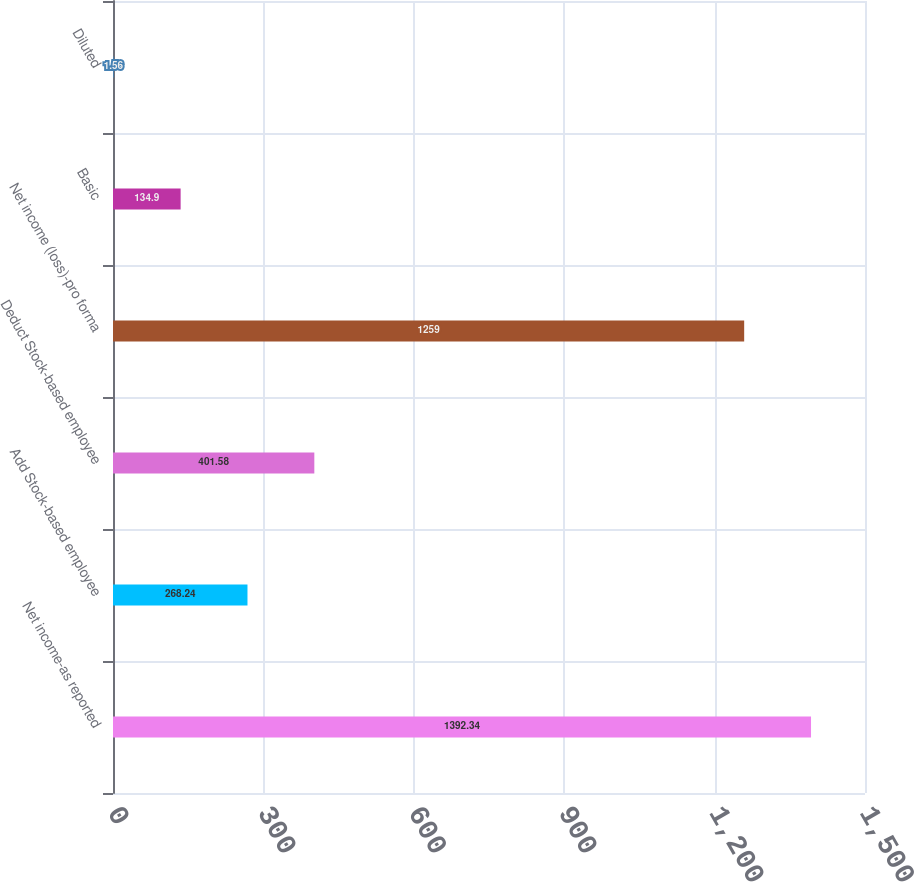<chart> <loc_0><loc_0><loc_500><loc_500><bar_chart><fcel>Net income-as reported<fcel>Add Stock-based employee<fcel>Deduct Stock-based employee<fcel>Net income (loss)-pro forma<fcel>Basic<fcel>Diluted<nl><fcel>1392.34<fcel>268.24<fcel>401.58<fcel>1259<fcel>134.9<fcel>1.56<nl></chart> 